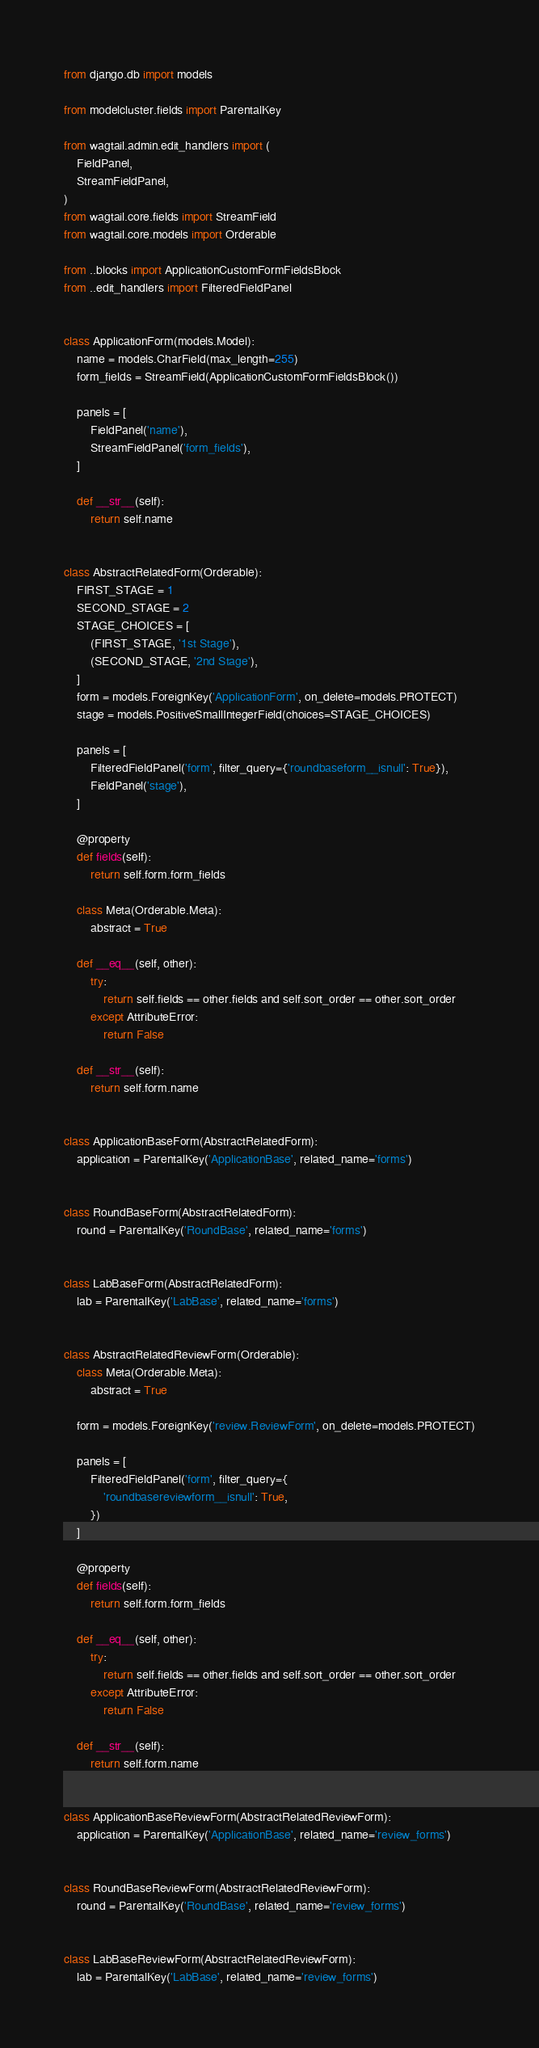<code> <loc_0><loc_0><loc_500><loc_500><_Python_>from django.db import models

from modelcluster.fields import ParentalKey

from wagtail.admin.edit_handlers import (
    FieldPanel,
    StreamFieldPanel,
)
from wagtail.core.fields import StreamField
from wagtail.core.models import Orderable

from ..blocks import ApplicationCustomFormFieldsBlock
from ..edit_handlers import FilteredFieldPanel


class ApplicationForm(models.Model):
    name = models.CharField(max_length=255)
    form_fields = StreamField(ApplicationCustomFormFieldsBlock())

    panels = [
        FieldPanel('name'),
        StreamFieldPanel('form_fields'),
    ]

    def __str__(self):
        return self.name


class AbstractRelatedForm(Orderable):
    FIRST_STAGE = 1
    SECOND_STAGE = 2
    STAGE_CHOICES = [
        (FIRST_STAGE, '1st Stage'),
        (SECOND_STAGE, '2nd Stage'),
    ]
    form = models.ForeignKey('ApplicationForm', on_delete=models.PROTECT)
    stage = models.PositiveSmallIntegerField(choices=STAGE_CHOICES)

    panels = [
        FilteredFieldPanel('form', filter_query={'roundbaseform__isnull': True}),
        FieldPanel('stage'),
    ]

    @property
    def fields(self):
        return self.form.form_fields

    class Meta(Orderable.Meta):
        abstract = True

    def __eq__(self, other):
        try:
            return self.fields == other.fields and self.sort_order == other.sort_order
        except AttributeError:
            return False

    def __str__(self):
        return self.form.name


class ApplicationBaseForm(AbstractRelatedForm):
    application = ParentalKey('ApplicationBase', related_name='forms')


class RoundBaseForm(AbstractRelatedForm):
    round = ParentalKey('RoundBase', related_name='forms')


class LabBaseForm(AbstractRelatedForm):
    lab = ParentalKey('LabBase', related_name='forms')


class AbstractRelatedReviewForm(Orderable):
    class Meta(Orderable.Meta):
        abstract = True

    form = models.ForeignKey('review.ReviewForm', on_delete=models.PROTECT)

    panels = [
        FilteredFieldPanel('form', filter_query={
            'roundbasereviewform__isnull': True,
        })
    ]

    @property
    def fields(self):
        return self.form.form_fields

    def __eq__(self, other):
        try:
            return self.fields == other.fields and self.sort_order == other.sort_order
        except AttributeError:
            return False

    def __str__(self):
        return self.form.name


class ApplicationBaseReviewForm(AbstractRelatedReviewForm):
    application = ParentalKey('ApplicationBase', related_name='review_forms')


class RoundBaseReviewForm(AbstractRelatedReviewForm):
    round = ParentalKey('RoundBase', related_name='review_forms')


class LabBaseReviewForm(AbstractRelatedReviewForm):
    lab = ParentalKey('LabBase', related_name='review_forms')
</code> 